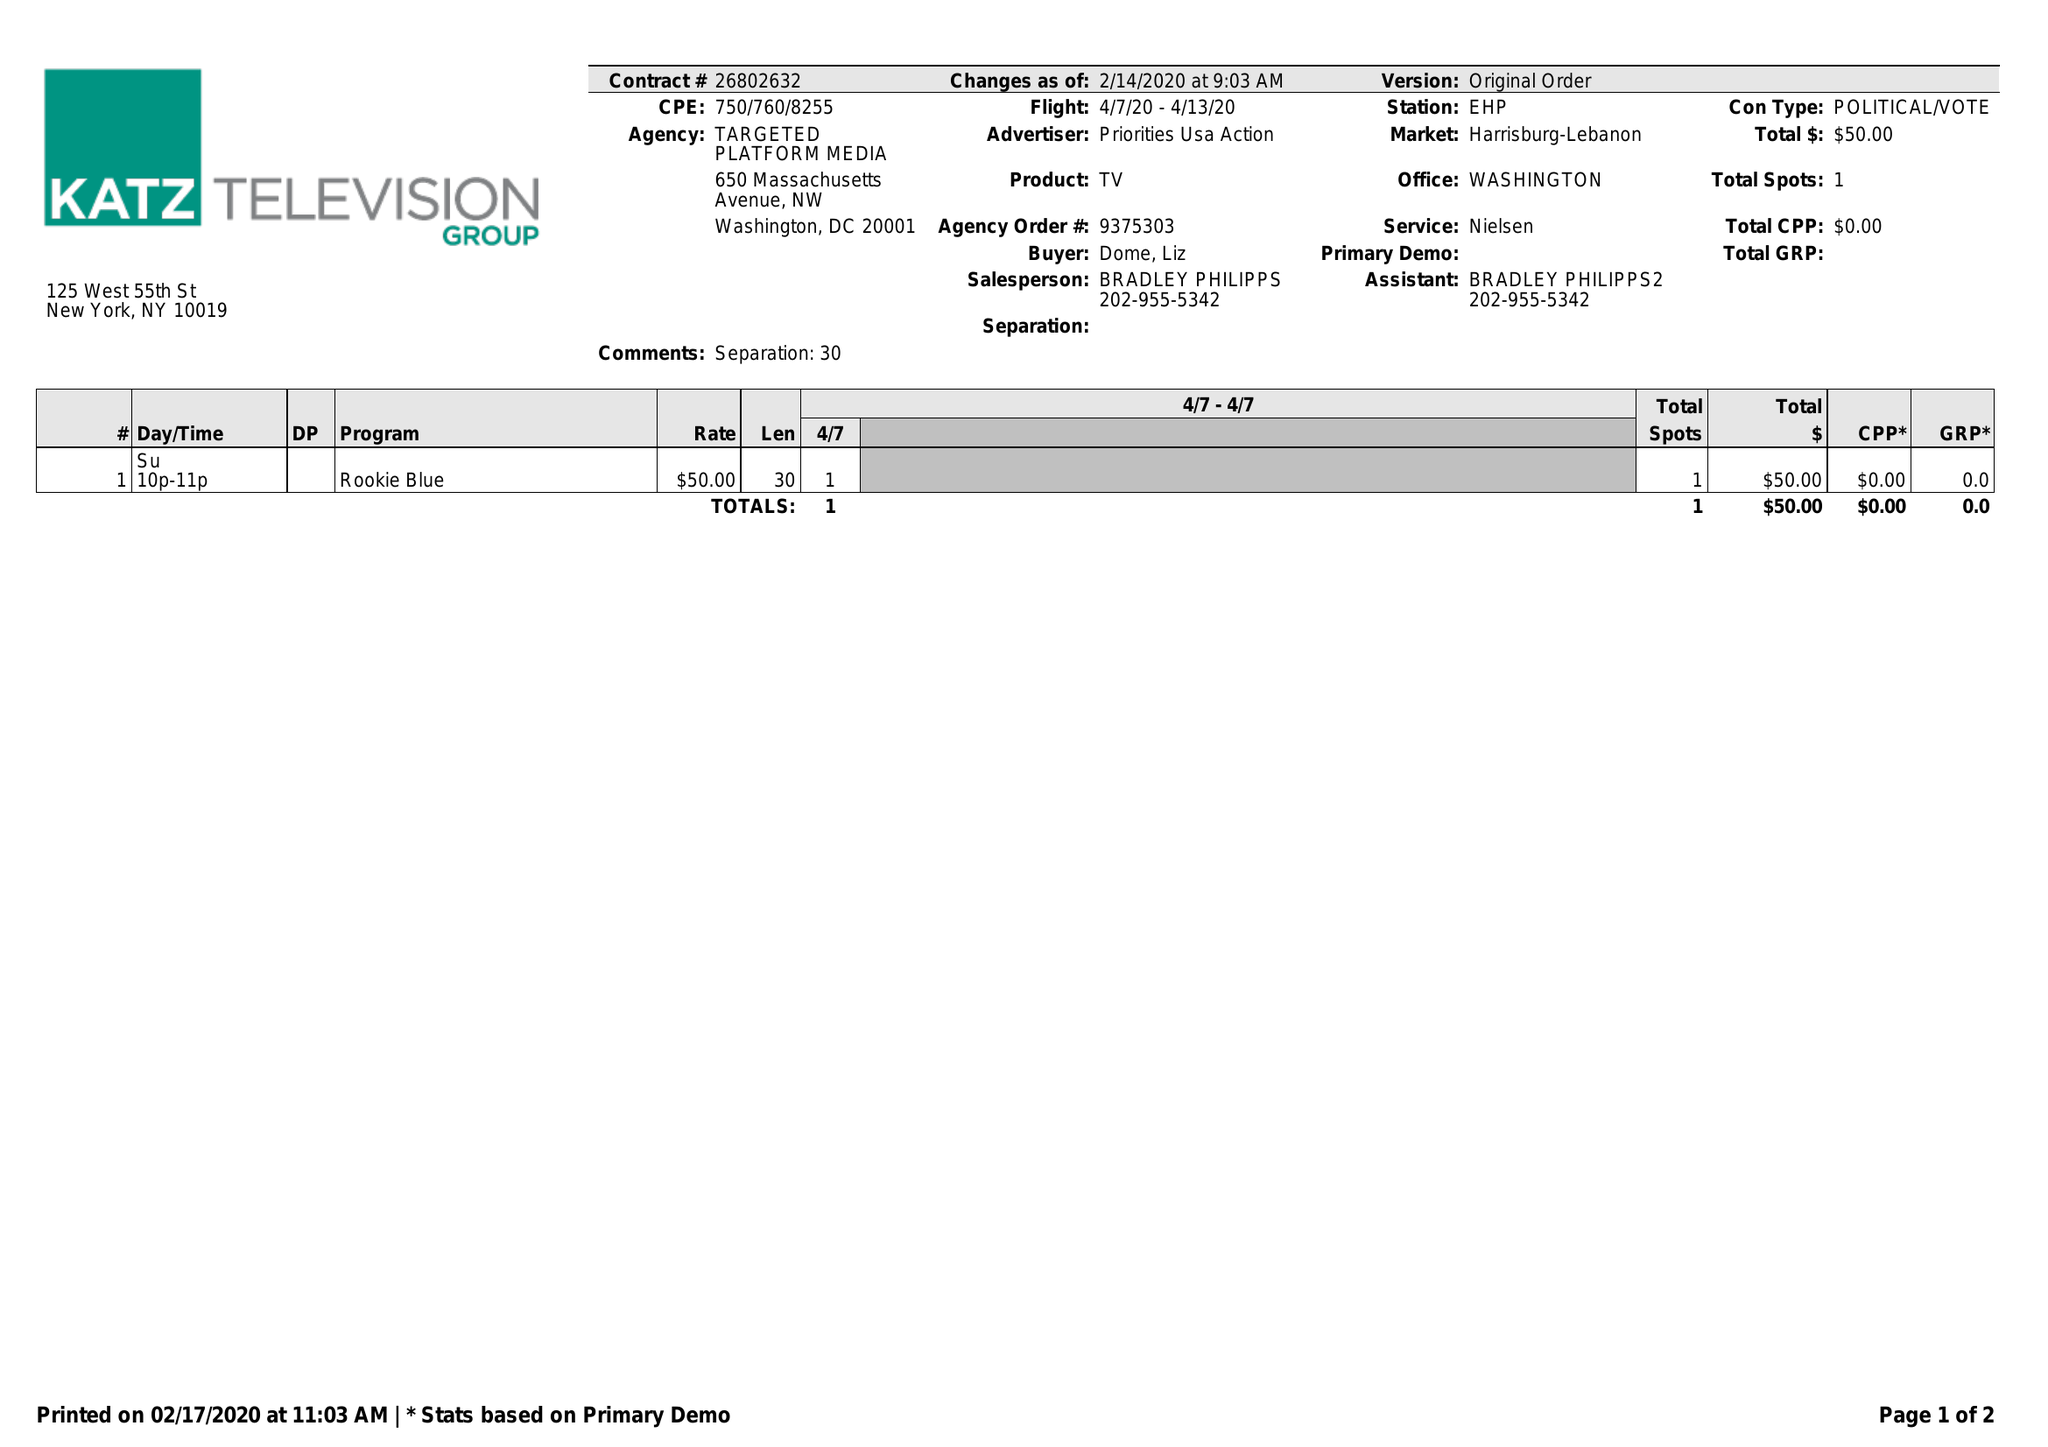What is the value for the contract_num?
Answer the question using a single word or phrase. 26802632 